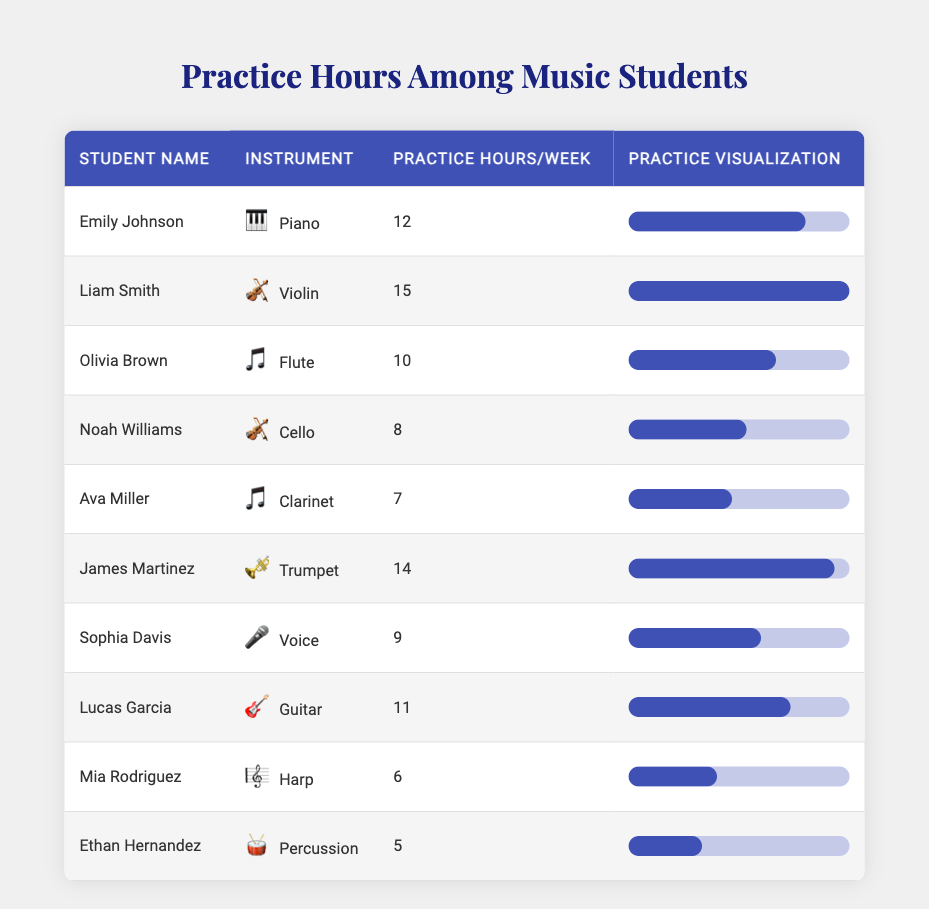What is the maximum number of practice hours per week among the students? The maximum practice hours per week is found by looking in the "Practice Hours/Week" column for the highest value. The highest value listed is 15 hours, which corresponds to Liam Smith.
Answer: 15 How many students practice for more than 10 hours per week? To find the number of students practicing for more than 10 hours, we check the "Practice Hours/Week" column and count the entries greater than 10. The selected students are Liam Smith, Emily Johnson, and James Martinez. This gives us a total of 3 students.
Answer: 3 What is the average practice hours per week for all students? The average is calculated by summing all the practice hours and dividing by the number of students. The sum of practice hours is 12 + 15 + 10 + 8 + 7 + 14 + 9 + 11 + 6 + 5 = 87. There are 10 students, so the average is 87 / 10 = 8.7.
Answer: 8.7 Is there any student practicing exactly 6 hours per week? We can check the "Practice Hours/Week" column for any entry that equals 6. The only student who practices exactly 6 hours is Mia Rodriguez. Therefore, the answer is yes.
Answer: Yes Which instrument has the least amount of practice hours and what is that number? By reviewing the "Practice Hours/Week" column, we find the lowest number, which is 5 hours practiced by Ethan Hernandez (Percussion). Therefore, the instrument is Percussion, and the number is 5.
Answer: Percussion, 5 If we group the students into two categories: more than 10 hours and 10 hours or less, how many are in each group? Students practicing more than 10 hours are Liam Smith, Emily Johnson, and James Martinez (total of 3). The students staying at or below 10 hours are Olivia Brown, Noah Williams, Ava Miller, Sophia Davis, Lucas Garcia, Mia Rodriguez, and Ethan Hernandez (a total of 7).
Answer: More than 10 hours: 3, 10 hours or less: 7 What is the difference in practice hours between the student with the highest and the lowest practice hours? The student with the highest practice hours is Liam Smith (15 hours), and the lowest is Ethan Hernandez (5 hours). To find the difference, we subtract the lower value from the higher: 15 - 5 = 10.
Answer: 10 How many students play string instruments (Violin, Cello, Guitar)? We need to identify how many students are associated with string instruments in the "Instrument" column. The string instruments are Violin (1), Cello (1), and Guitar (1), giving us a total of 3 students.
Answer: 3 